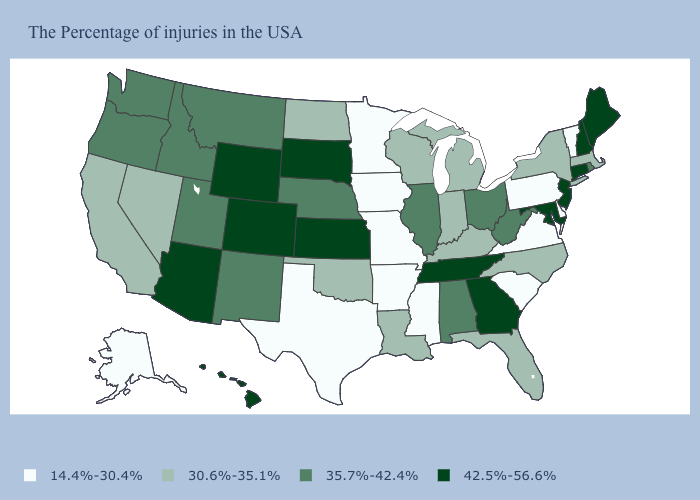How many symbols are there in the legend?
Short answer required. 4. Among the states that border Mississippi , does Tennessee have the highest value?
Quick response, please. Yes. What is the value of Delaware?
Concise answer only. 14.4%-30.4%. Does Rhode Island have a higher value than Oregon?
Concise answer only. No. Does Arkansas have the same value as Alaska?
Be succinct. Yes. Does Hawaii have the highest value in the West?
Keep it brief. Yes. What is the value of Iowa?
Keep it brief. 14.4%-30.4%. Which states have the lowest value in the MidWest?
Write a very short answer. Missouri, Minnesota, Iowa. What is the value of South Carolina?
Be succinct. 14.4%-30.4%. Which states hav the highest value in the Northeast?
Short answer required. Maine, New Hampshire, Connecticut, New Jersey. Does New York have a lower value than Texas?
Answer briefly. No. Which states hav the highest value in the West?
Short answer required. Wyoming, Colorado, Arizona, Hawaii. What is the value of Virginia?
Concise answer only. 14.4%-30.4%. Which states have the lowest value in the USA?
Concise answer only. Vermont, Delaware, Pennsylvania, Virginia, South Carolina, Mississippi, Missouri, Arkansas, Minnesota, Iowa, Texas, Alaska. What is the value of Wisconsin?
Short answer required. 30.6%-35.1%. 